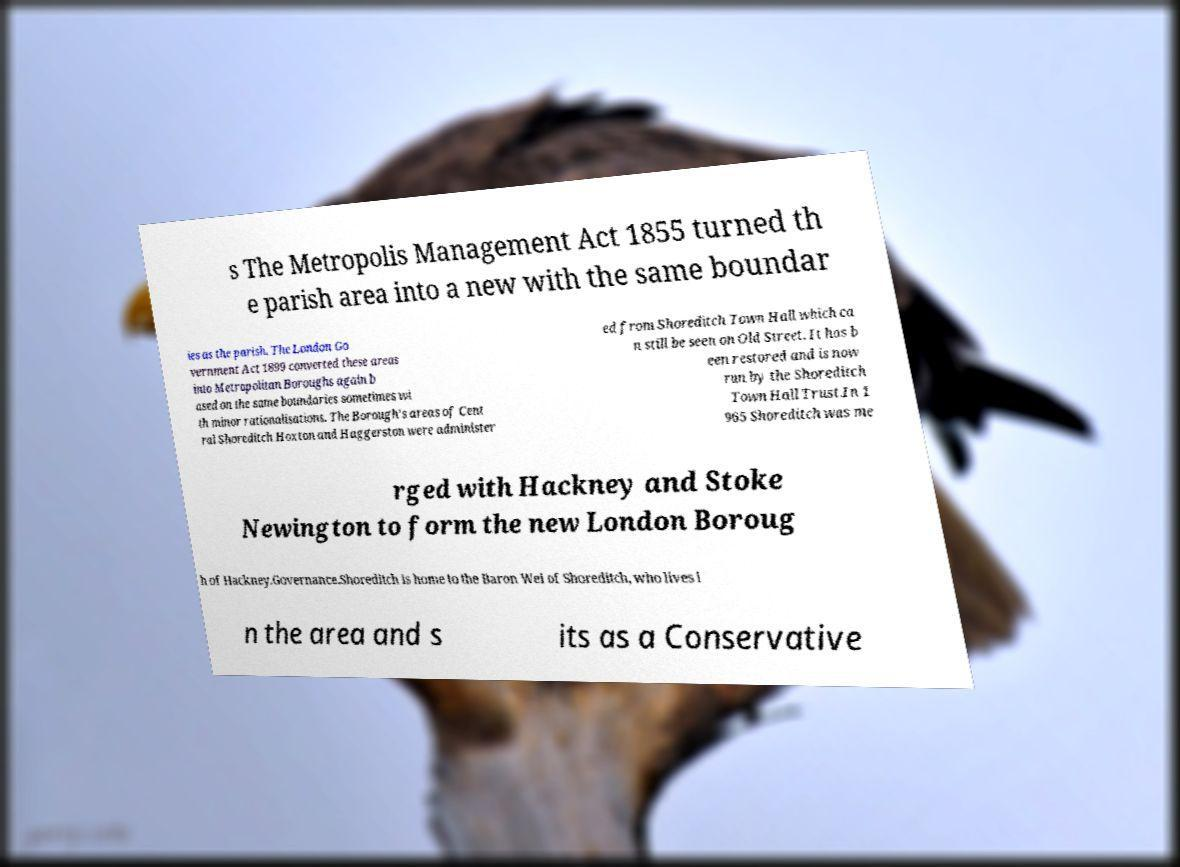Could you extract and type out the text from this image? s The Metropolis Management Act 1855 turned th e parish area into a new with the same boundar ies as the parish. The London Go vernment Act 1899 converted these areas into Metropolitan Boroughs again b ased on the same boundaries sometimes wi th minor rationalisations. The Borough's areas of Cent ral Shoreditch Hoxton and Haggerston were administer ed from Shoreditch Town Hall which ca n still be seen on Old Street. It has b een restored and is now run by the Shoreditch Town Hall Trust.In 1 965 Shoreditch was me rged with Hackney and Stoke Newington to form the new London Boroug h of Hackney.Governance.Shoreditch is home to the Baron Wei of Shoreditch, who lives i n the area and s its as a Conservative 